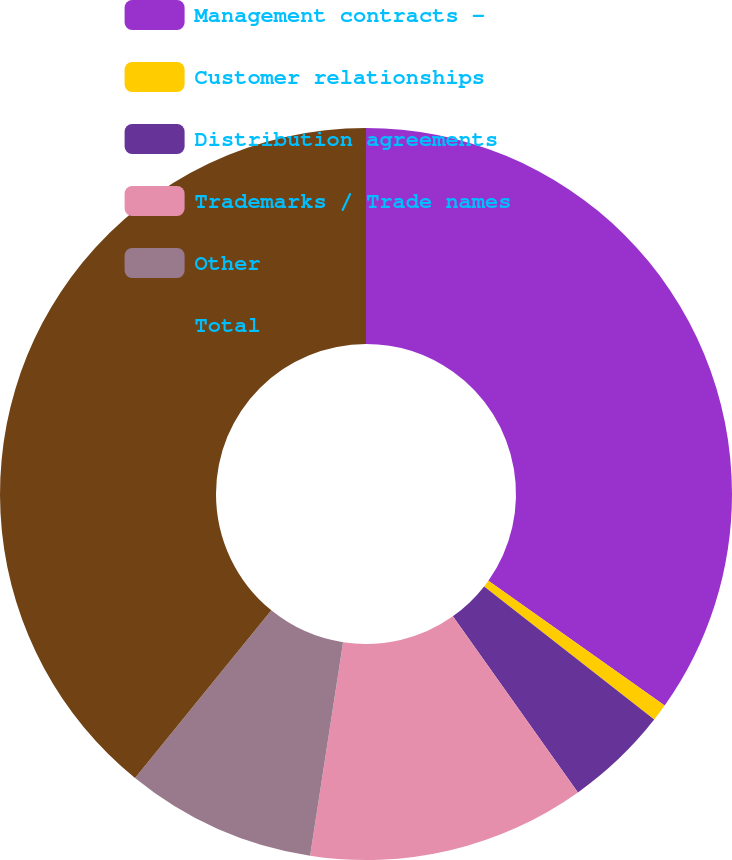Convert chart to OTSL. <chart><loc_0><loc_0><loc_500><loc_500><pie_chart><fcel>Management contracts -<fcel>Customer relationships<fcel>Distribution agreements<fcel>Trademarks / Trade names<fcel>Other<fcel>Total<nl><fcel>34.81%<fcel>0.76%<fcel>4.6%<fcel>12.27%<fcel>8.43%<fcel>39.13%<nl></chart> 